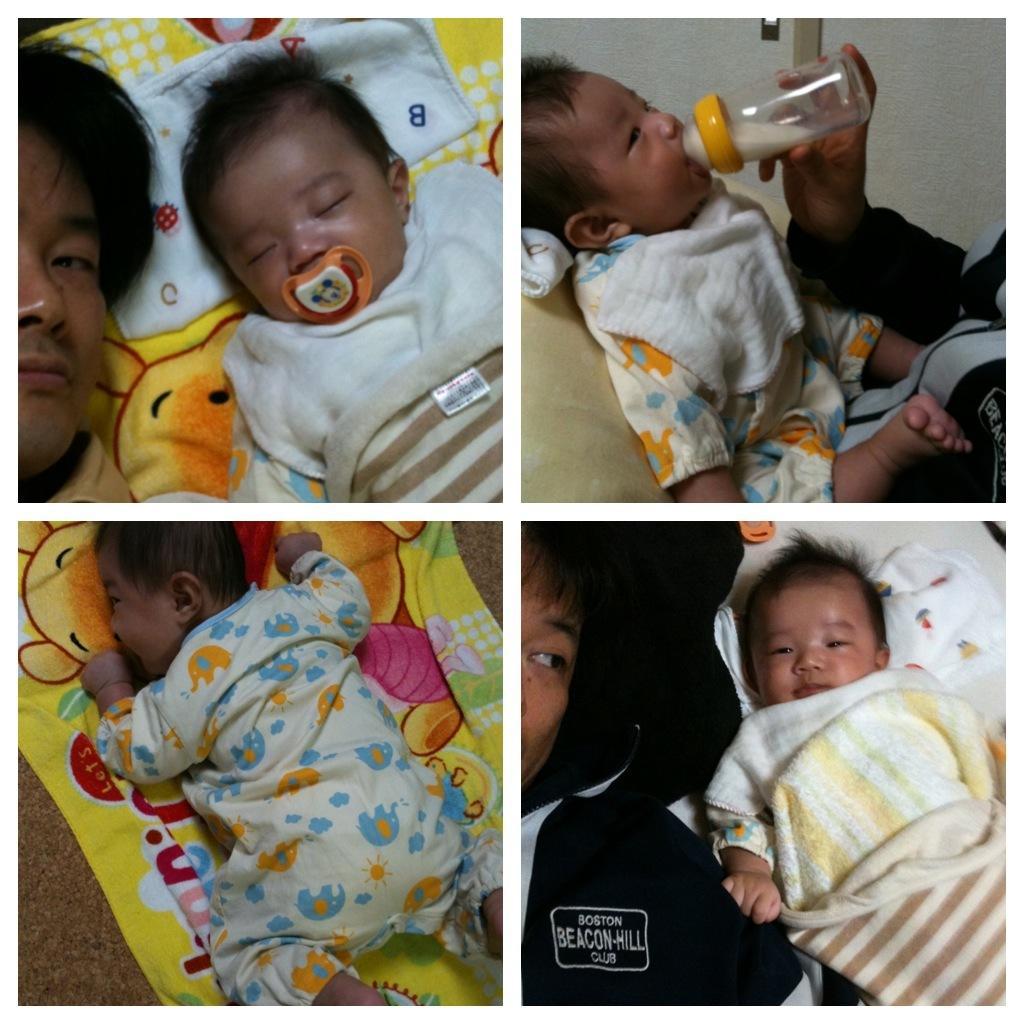Could you give a brief overview of what you see in this image? In this image there is a baby sleeping in the blanket ,baby drinking the milk , baby sleeping in the blanket under the carpet , a person sleeping behind the baby. 